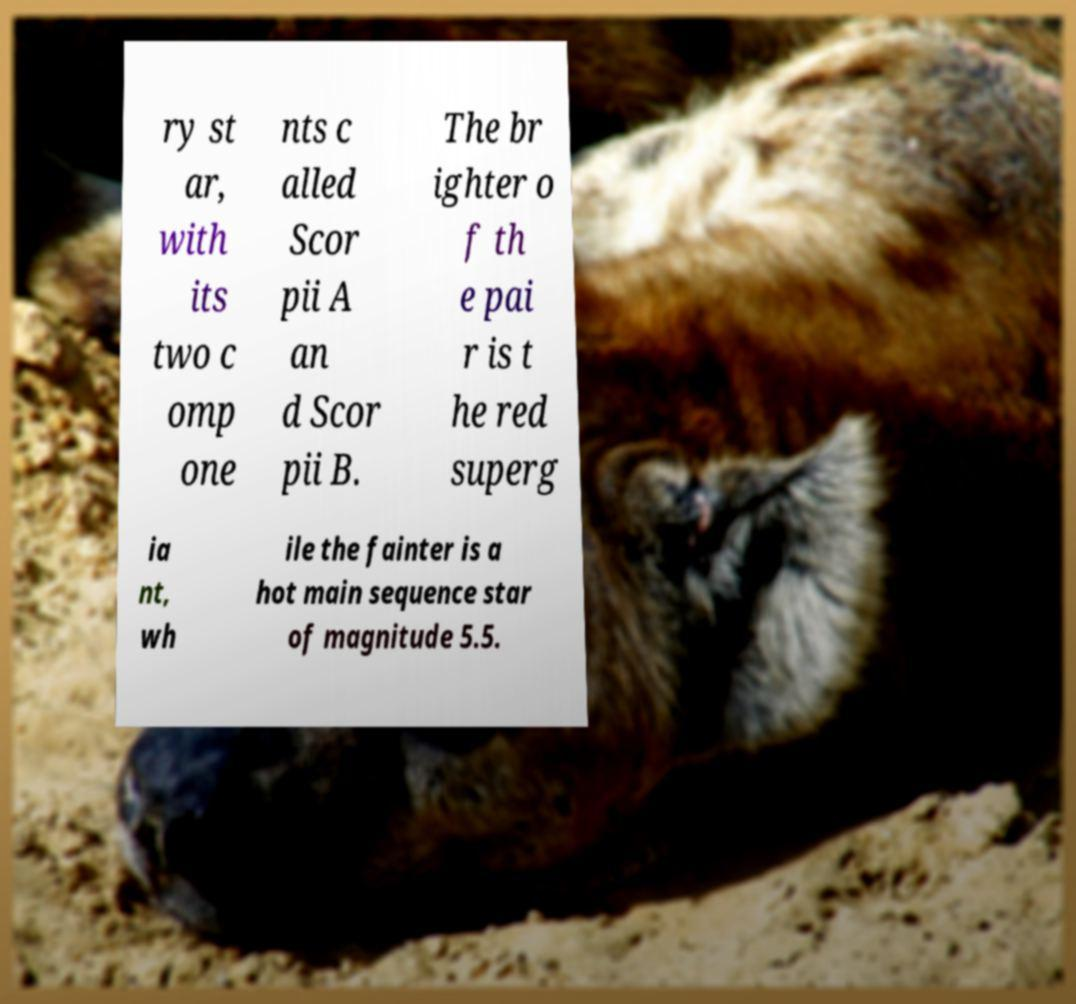For documentation purposes, I need the text within this image transcribed. Could you provide that? ry st ar, with its two c omp one nts c alled Scor pii A an d Scor pii B. The br ighter o f th e pai r is t he red superg ia nt, wh ile the fainter is a hot main sequence star of magnitude 5.5. 